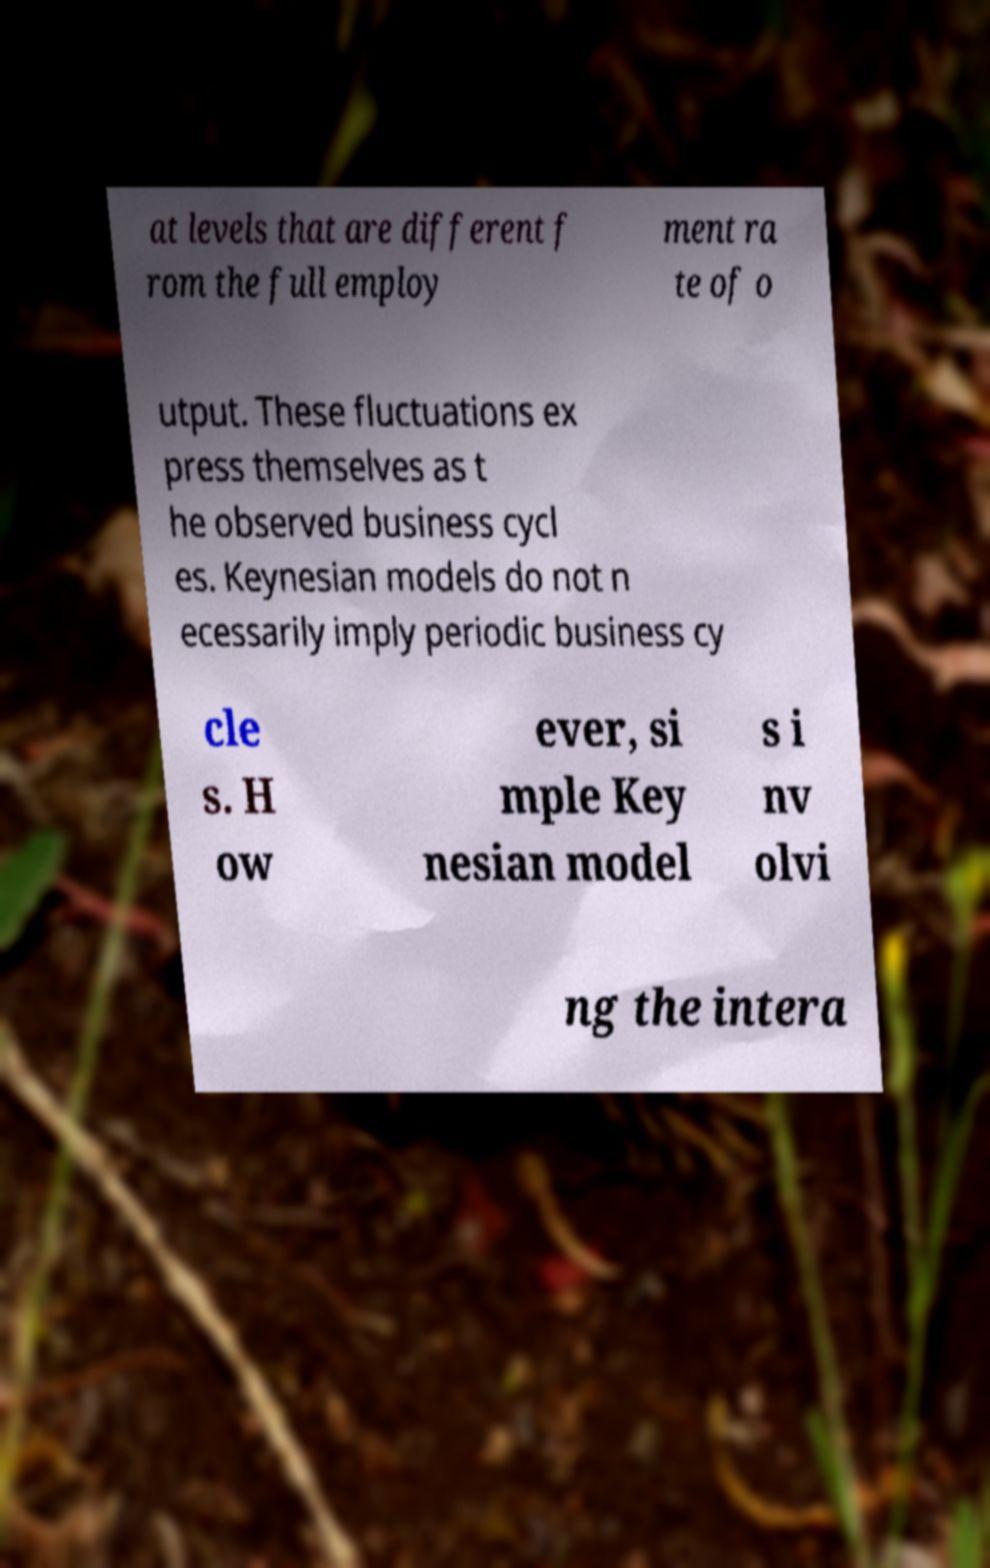There's text embedded in this image that I need extracted. Can you transcribe it verbatim? at levels that are different f rom the full employ ment ra te of o utput. These fluctuations ex press themselves as t he observed business cycl es. Keynesian models do not n ecessarily imply periodic business cy cle s. H ow ever, si mple Key nesian model s i nv olvi ng the intera 